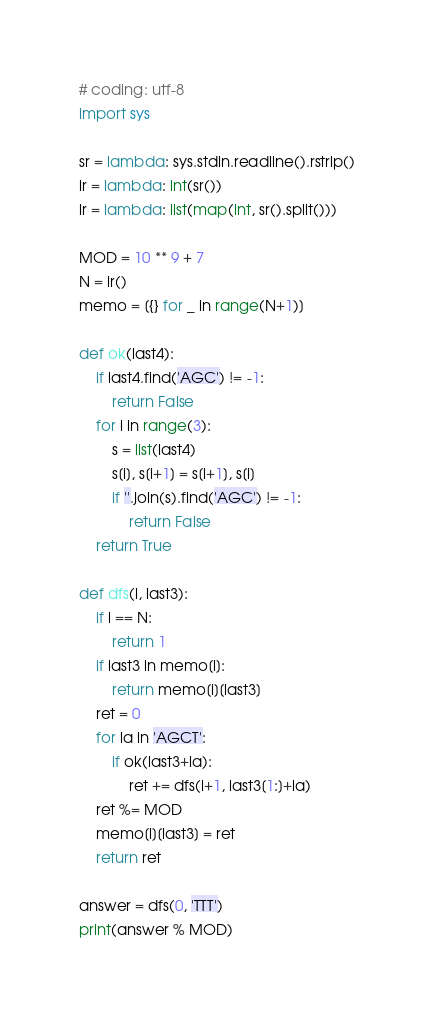<code> <loc_0><loc_0><loc_500><loc_500><_Python_># coding: utf-8
import sys

sr = lambda: sys.stdin.readline().rstrip()
ir = lambda: int(sr())
lr = lambda: list(map(int, sr().split()))

MOD = 10 ** 9 + 7
N = ir()
memo = [{} for _ in range(N+1)]

def ok(last4):
    if last4.find('AGC') != -1:
        return False
    for i in range(3):
        s = list(last4)
        s[i], s[i+1] = s[i+1], s[i]
        if ''.join(s).find('AGC') != -1:
            return False
    return True

def dfs(i, last3):
    if i == N:
        return 1
    if last3 in memo[i]:
        return memo[i][last3]
    ret = 0
    for la in 'AGCT':
        if ok(last3+la):
            ret += dfs(i+1, last3[1:]+la)
    ret %= MOD
    memo[i][last3] = ret
    return ret

answer = dfs(0, 'TTT')
print(answer % MOD)
</code> 